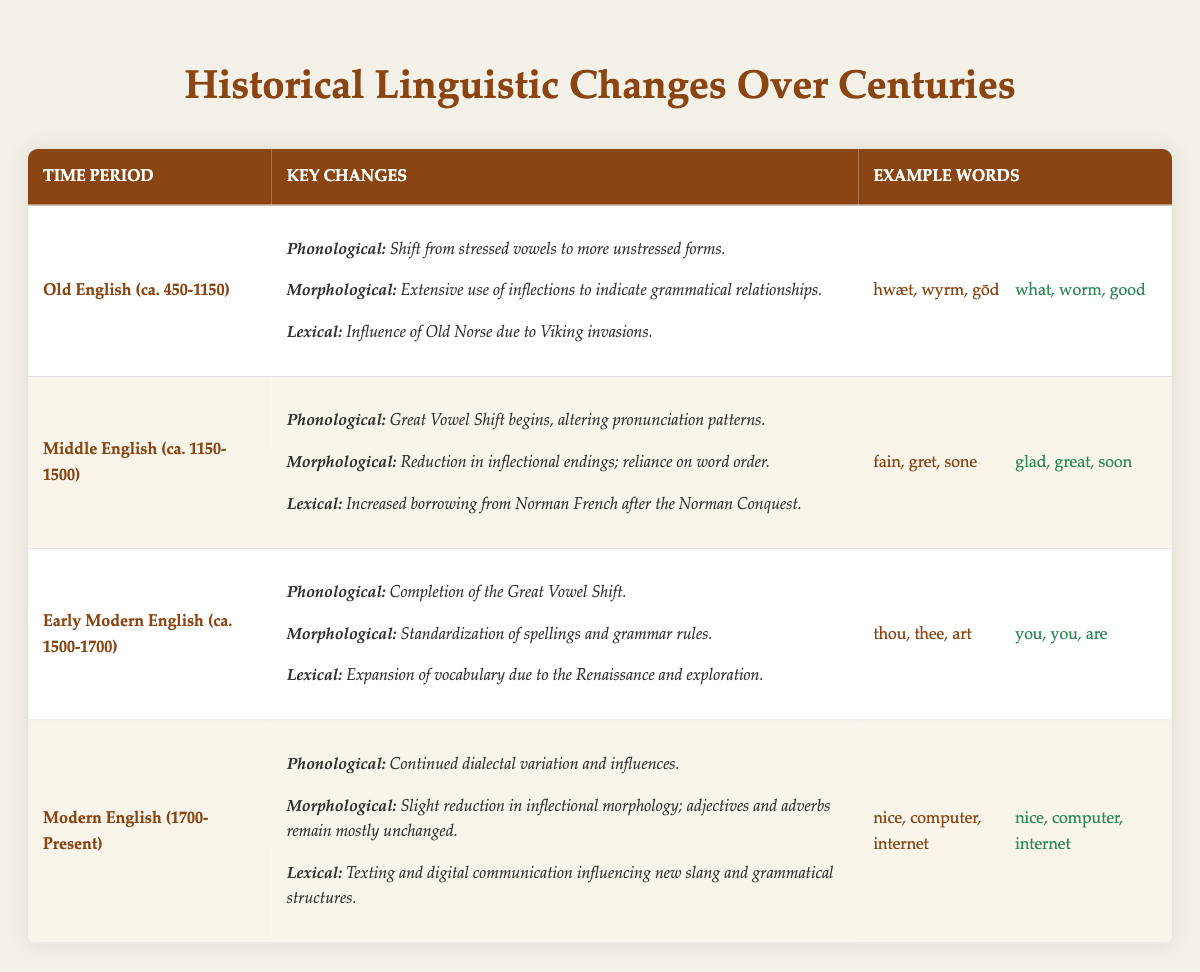What are the example words from the Old English period? According to the table, the example words from the Old English period are “hwæt,” “wyrm,” and “gōd.” These words are provided in the section under the "Example Words" column for Old English.
Answer: hwæt, wyrm, gōd Is the Great Vowel Shift associated with Middle English? The table indicates that the Great Vowel Shift begins during the Middle English period. Therefore, the statement is true.
Answer: Yes What was a key phonological change in Early Modern English? The table states that the key phonological change in Early Modern English is the completion of the Great Vowel Shift. This can be found in the "Key Changes" section for that time period.
Answer: Completion of the Great Vowel Shift Which time period had the most borrowing from Norman French? The table shows that the Middle English period experienced increased borrowing from Norman French, particularly after the Norman Conquest. This information is noted in the "Lexical" changes section for Middle English.
Answer: Middle English Are there any example words that remained unchanged from Old English to Modern English? According to the table, example words like “computer” and “internet” appear unchanged in Modern English. This confirms that there are words that have not evolved over time.
Answer: Yes Which time period saw extensive use of inflections for grammatical relationships? The table clearly states that the Old English period (ca. 450-1150) had extensive use of inflections to indicate grammatical relationships, as described under the "Morphological" key changes.
Answer: Old English If you were to compare the phonological changes between Old English and Modern English, what does the table reveal? Analyzing the table, Old English emphasizes a shift from stressed vowels to more unstressed forms, while Modern English displays continued dialectal variation and influences. Thus, there is an evolution from a more inflected and stressed vowel system to one that is less inflected and more varied.
Answer: Stress shifts and dialectal variation How many key changes are noted for the Early Modern English period? Referring to the table, three key changes are noted for the Early Modern English period: phonological change, morphological change, and lexical expansion. Each change is listed explicitly under the "Key Changes" column.
Answer: Three changes What does the lexical change in Modern English indicate about language evolution? The table indicates that lexical changes in Modern English are influenced by texting and digital communication, illustrating how technology and culture shape language. This insight suggests an ongoing evolution influenced by modern practices.
Answer: Influence of technology and culture 